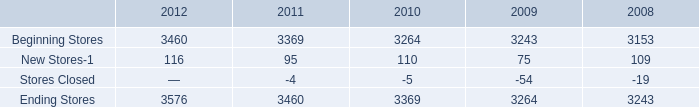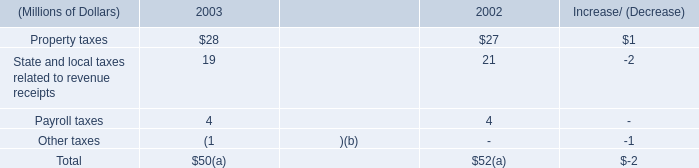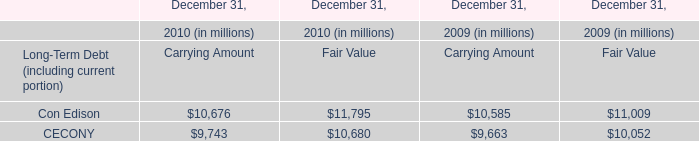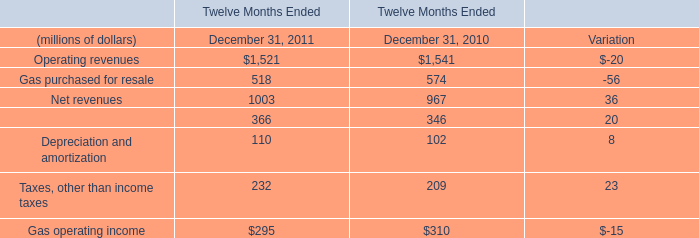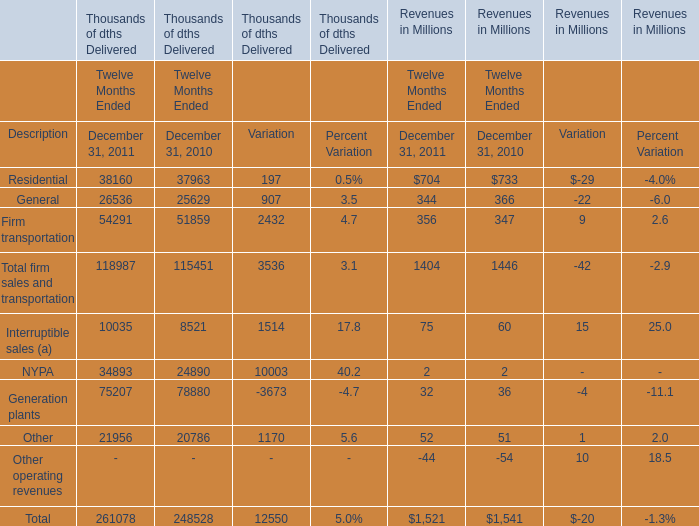What's the current increasing rate of Revenues of Firm transportation? 
Computations: ((356 - 347) / 347)
Answer: 0.02594. 